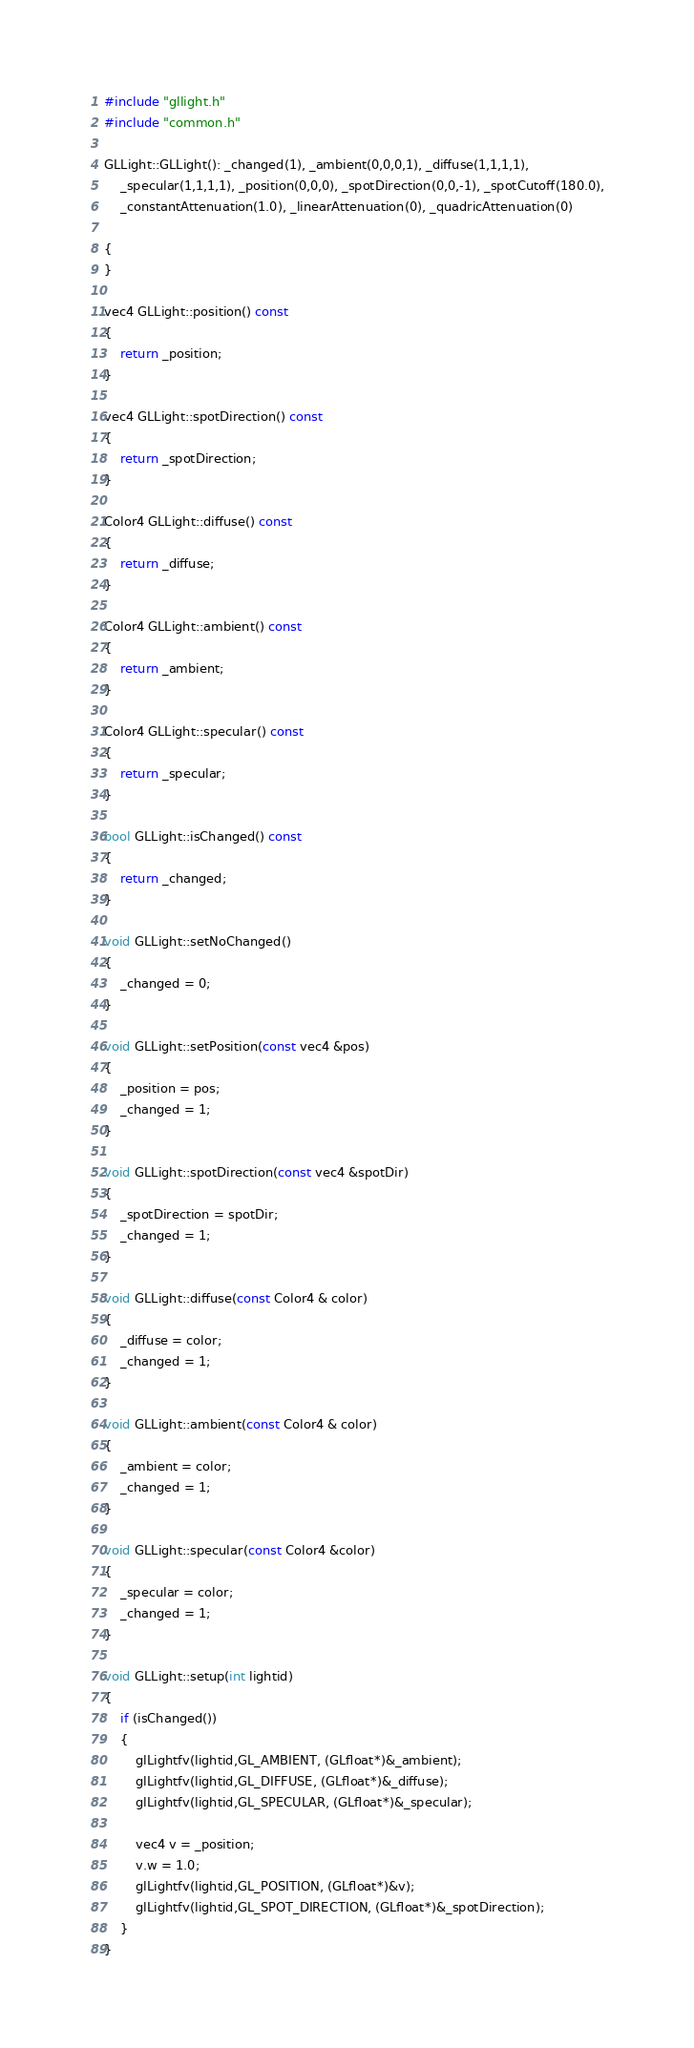Convert code to text. <code><loc_0><loc_0><loc_500><loc_500><_C++_>#include "gllight.h"
#include "common.h"

GLLight::GLLight(): _changed(1), _ambient(0,0,0,1), _diffuse(1,1,1,1),
    _specular(1,1,1,1), _position(0,0,0), _spotDirection(0,0,-1), _spotCutoff(180.0),
    _constantAttenuation(1.0), _linearAttenuation(0), _quadricAttenuation(0)

{
}

vec4 GLLight::position() const
{
    return _position;
}

vec4 GLLight::spotDirection() const
{
    return _spotDirection;
}

Color4 GLLight::diffuse() const
{
    return _diffuse;
}

Color4 GLLight::ambient() const
{
    return _ambient;
}

Color4 GLLight::specular() const
{
    return _specular;
}

bool GLLight::isChanged() const
{
    return _changed;
}

void GLLight::setNoChanged()
{
    _changed = 0;
}

void GLLight::setPosition(const vec4 &pos)
{
    _position = pos;
    _changed = 1;
}

void GLLight::spotDirection(const vec4 &spotDir)
{
    _spotDirection = spotDir;
    _changed = 1;
}

void GLLight::diffuse(const Color4 & color)
{
    _diffuse = color;
    _changed = 1;
}

void GLLight::ambient(const Color4 & color)
{
    _ambient = color;
    _changed = 1;
}

void GLLight::specular(const Color4 &color)
{
    _specular = color;
    _changed = 1;
}

void GLLight::setup(int lightid)
{
    if (isChanged())
    {
        glLightfv(lightid,GL_AMBIENT, (GLfloat*)&_ambient);
        glLightfv(lightid,GL_DIFFUSE, (GLfloat*)&_diffuse);
        glLightfv(lightid,GL_SPECULAR, (GLfloat*)&_specular);

        vec4 v = _position;
        v.w = 1.0;
        glLightfv(lightid,GL_POSITION, (GLfloat*)&v);
        glLightfv(lightid,GL_SPOT_DIRECTION, (GLfloat*)&_spotDirection);
    }
}
</code> 